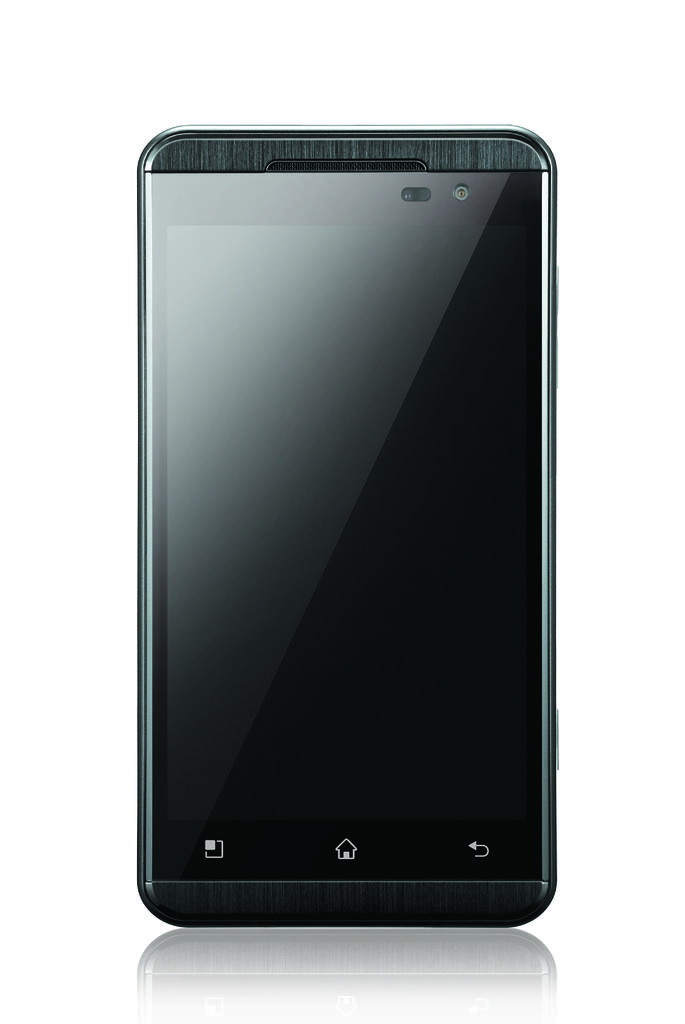What object is the main subject of the image? There is a mobile in the image. What color is the mobile? The mobile is black in color. What is the color of the background in the image? The background of the image is white. What type of toad can be seen expressing anger in the image? There is no toad or any indication of anger present in the image; it features a black mobile against a white background. 